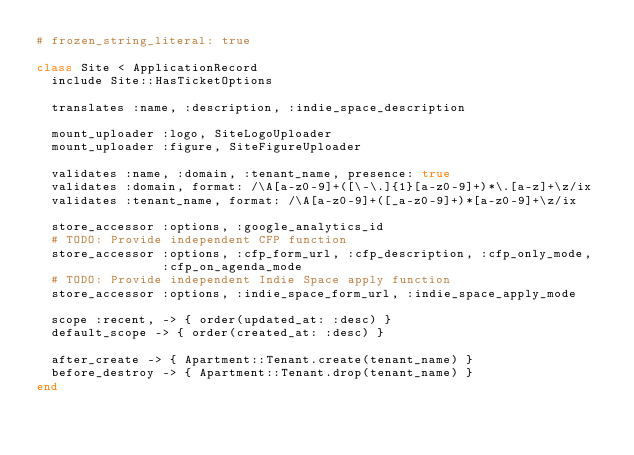<code> <loc_0><loc_0><loc_500><loc_500><_Ruby_># frozen_string_literal: true

class Site < ApplicationRecord
  include Site::HasTicketOptions

  translates :name, :description, :indie_space_description

  mount_uploader :logo, SiteLogoUploader
  mount_uploader :figure, SiteFigureUploader

  validates :name, :domain, :tenant_name, presence: true
  validates :domain, format: /\A[a-z0-9]+([\-\.]{1}[a-z0-9]+)*\.[a-z]+\z/ix
  validates :tenant_name, format: /\A[a-z0-9]+([_a-z0-9]+)*[a-z0-9]+\z/ix

  store_accessor :options, :google_analytics_id
  # TODO: Provide independent CFP function
  store_accessor :options, :cfp_form_url, :cfp_description, :cfp_only_mode,
                 :cfp_on_agenda_mode
  # TODO: Provide independent Indie Space apply function
  store_accessor :options, :indie_space_form_url, :indie_space_apply_mode

  scope :recent, -> { order(updated_at: :desc) }
  default_scope -> { order(created_at: :desc) }

  after_create -> { Apartment::Tenant.create(tenant_name) }
  before_destroy -> { Apartment::Tenant.drop(tenant_name) }
end
</code> 